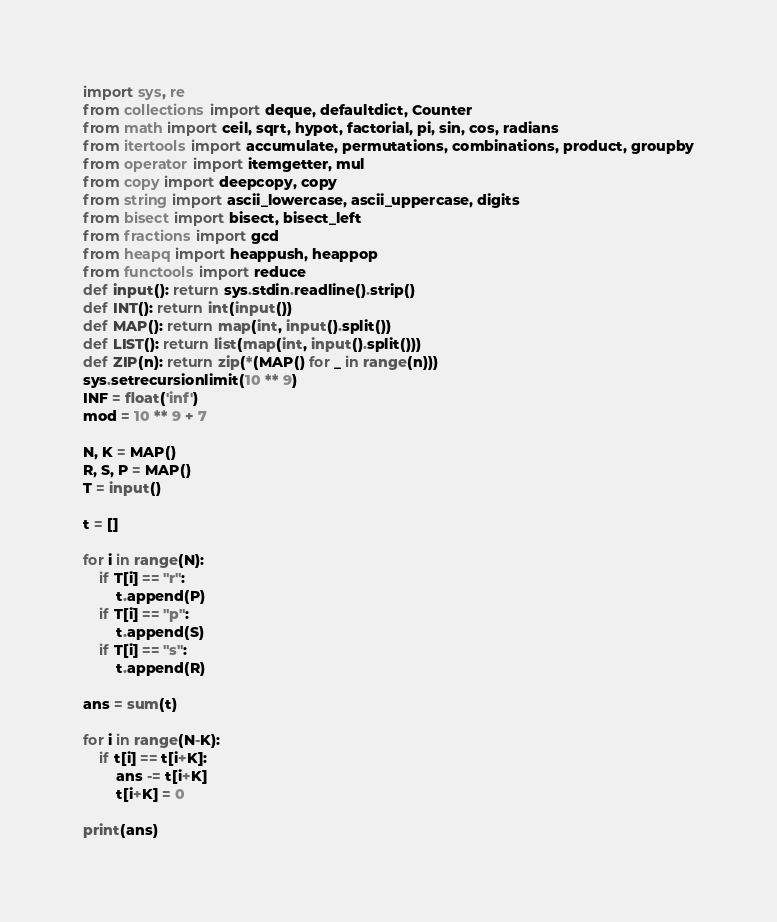Convert code to text. <code><loc_0><loc_0><loc_500><loc_500><_Python_>import sys, re
from collections import deque, defaultdict, Counter
from math import ceil, sqrt, hypot, factorial, pi, sin, cos, radians
from itertools import accumulate, permutations, combinations, product, groupby
from operator import itemgetter, mul
from copy import deepcopy, copy
from string import ascii_lowercase, ascii_uppercase, digits
from bisect import bisect, bisect_left
from fractions import gcd
from heapq import heappush, heappop
from functools import reduce
def input(): return sys.stdin.readline().strip()
def INT(): return int(input())
def MAP(): return map(int, input().split())
def LIST(): return list(map(int, input().split()))
def ZIP(n): return zip(*(MAP() for _ in range(n)))
sys.setrecursionlimit(10 ** 9)
INF = float('inf')
mod = 10 ** 9 + 7

N, K = MAP()
R, S, P = MAP()
T = input()

t = []

for i in range(N):
	if T[i] == "r":
		t.append(P)
	if T[i] == "p":
		t.append(S)
	if T[i] == "s":
		t.append(R)

ans = sum(t)

for i in range(N-K):
	if t[i] == t[i+K]:
		ans -= t[i+K]
		t[i+K] = 0

print(ans)</code> 